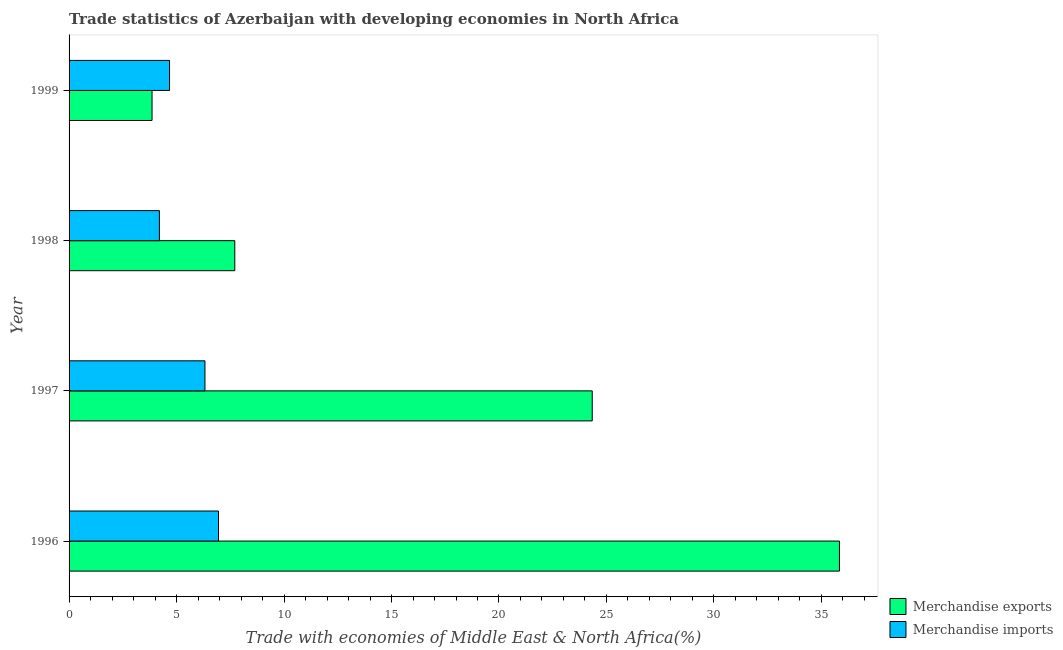How many different coloured bars are there?
Offer a terse response. 2. Are the number of bars on each tick of the Y-axis equal?
Provide a succinct answer. Yes. How many bars are there on the 4th tick from the top?
Your answer should be compact. 2. How many bars are there on the 4th tick from the bottom?
Keep it short and to the point. 2. What is the label of the 3rd group of bars from the top?
Your response must be concise. 1997. In how many cases, is the number of bars for a given year not equal to the number of legend labels?
Your response must be concise. 0. What is the merchandise imports in 1996?
Provide a succinct answer. 6.95. Across all years, what is the maximum merchandise exports?
Your response must be concise. 35.84. Across all years, what is the minimum merchandise exports?
Keep it short and to the point. 3.86. What is the total merchandise imports in the graph?
Your response must be concise. 22.15. What is the difference between the merchandise exports in 1997 and that in 1998?
Your response must be concise. 16.63. What is the difference between the merchandise exports in 1999 and the merchandise imports in 1998?
Your answer should be very brief. -0.34. What is the average merchandise imports per year?
Keep it short and to the point. 5.54. In the year 1996, what is the difference between the merchandise exports and merchandise imports?
Give a very brief answer. 28.89. In how many years, is the merchandise imports greater than 7 %?
Provide a succinct answer. 0. What is the ratio of the merchandise exports in 1996 to that in 1999?
Keep it short and to the point. 9.29. Is the merchandise exports in 1996 less than that in 1999?
Make the answer very short. No. Is the difference between the merchandise exports in 1997 and 1998 greater than the difference between the merchandise imports in 1997 and 1998?
Your response must be concise. Yes. What is the difference between the highest and the lowest merchandise imports?
Ensure brevity in your answer.  2.75. Is the sum of the merchandise exports in 1996 and 1999 greater than the maximum merchandise imports across all years?
Offer a very short reply. Yes. What does the 2nd bar from the top in 1999 represents?
Provide a short and direct response. Merchandise exports. How many years are there in the graph?
Your response must be concise. 4. What is the difference between two consecutive major ticks on the X-axis?
Make the answer very short. 5. Does the graph contain any zero values?
Your response must be concise. No. Does the graph contain grids?
Give a very brief answer. No. Where does the legend appear in the graph?
Provide a short and direct response. Bottom right. How many legend labels are there?
Your answer should be compact. 2. What is the title of the graph?
Provide a short and direct response. Trade statistics of Azerbaijan with developing economies in North Africa. What is the label or title of the X-axis?
Offer a terse response. Trade with economies of Middle East & North Africa(%). What is the label or title of the Y-axis?
Keep it short and to the point. Year. What is the Trade with economies of Middle East & North Africa(%) of Merchandise exports in 1996?
Provide a succinct answer. 35.84. What is the Trade with economies of Middle East & North Africa(%) of Merchandise imports in 1996?
Your answer should be compact. 6.95. What is the Trade with economies of Middle East & North Africa(%) in Merchandise exports in 1997?
Ensure brevity in your answer.  24.34. What is the Trade with economies of Middle East & North Africa(%) in Merchandise imports in 1997?
Keep it short and to the point. 6.32. What is the Trade with economies of Middle East & North Africa(%) in Merchandise exports in 1998?
Give a very brief answer. 7.71. What is the Trade with economies of Middle East & North Africa(%) of Merchandise imports in 1998?
Provide a short and direct response. 4.2. What is the Trade with economies of Middle East & North Africa(%) of Merchandise exports in 1999?
Your response must be concise. 3.86. What is the Trade with economies of Middle East & North Africa(%) in Merchandise imports in 1999?
Make the answer very short. 4.67. Across all years, what is the maximum Trade with economies of Middle East & North Africa(%) in Merchandise exports?
Ensure brevity in your answer.  35.84. Across all years, what is the maximum Trade with economies of Middle East & North Africa(%) of Merchandise imports?
Keep it short and to the point. 6.95. Across all years, what is the minimum Trade with economies of Middle East & North Africa(%) in Merchandise exports?
Offer a terse response. 3.86. Across all years, what is the minimum Trade with economies of Middle East & North Africa(%) of Merchandise imports?
Ensure brevity in your answer.  4.2. What is the total Trade with economies of Middle East & North Africa(%) of Merchandise exports in the graph?
Your response must be concise. 71.75. What is the total Trade with economies of Middle East & North Africa(%) in Merchandise imports in the graph?
Provide a succinct answer. 22.15. What is the difference between the Trade with economies of Middle East & North Africa(%) in Merchandise exports in 1996 and that in 1997?
Offer a very short reply. 11.5. What is the difference between the Trade with economies of Middle East & North Africa(%) in Merchandise imports in 1996 and that in 1997?
Make the answer very short. 0.63. What is the difference between the Trade with economies of Middle East & North Africa(%) in Merchandise exports in 1996 and that in 1998?
Give a very brief answer. 28.13. What is the difference between the Trade with economies of Middle East & North Africa(%) of Merchandise imports in 1996 and that in 1998?
Offer a very short reply. 2.75. What is the difference between the Trade with economies of Middle East & North Africa(%) in Merchandise exports in 1996 and that in 1999?
Your answer should be compact. 31.98. What is the difference between the Trade with economies of Middle East & North Africa(%) in Merchandise imports in 1996 and that in 1999?
Your response must be concise. 2.28. What is the difference between the Trade with economies of Middle East & North Africa(%) of Merchandise exports in 1997 and that in 1998?
Your response must be concise. 16.63. What is the difference between the Trade with economies of Middle East & North Africa(%) of Merchandise imports in 1997 and that in 1998?
Your answer should be compact. 2.12. What is the difference between the Trade with economies of Middle East & North Africa(%) in Merchandise exports in 1997 and that in 1999?
Your answer should be compact. 20.48. What is the difference between the Trade with economies of Middle East & North Africa(%) in Merchandise imports in 1997 and that in 1999?
Ensure brevity in your answer.  1.65. What is the difference between the Trade with economies of Middle East & North Africa(%) in Merchandise exports in 1998 and that in 1999?
Give a very brief answer. 3.85. What is the difference between the Trade with economies of Middle East & North Africa(%) of Merchandise imports in 1998 and that in 1999?
Ensure brevity in your answer.  -0.47. What is the difference between the Trade with economies of Middle East & North Africa(%) in Merchandise exports in 1996 and the Trade with economies of Middle East & North Africa(%) in Merchandise imports in 1997?
Ensure brevity in your answer.  29.52. What is the difference between the Trade with economies of Middle East & North Africa(%) in Merchandise exports in 1996 and the Trade with economies of Middle East & North Africa(%) in Merchandise imports in 1998?
Provide a succinct answer. 31.64. What is the difference between the Trade with economies of Middle East & North Africa(%) of Merchandise exports in 1996 and the Trade with economies of Middle East & North Africa(%) of Merchandise imports in 1999?
Make the answer very short. 31.16. What is the difference between the Trade with economies of Middle East & North Africa(%) in Merchandise exports in 1997 and the Trade with economies of Middle East & North Africa(%) in Merchandise imports in 1998?
Provide a succinct answer. 20.14. What is the difference between the Trade with economies of Middle East & North Africa(%) in Merchandise exports in 1997 and the Trade with economies of Middle East & North Africa(%) in Merchandise imports in 1999?
Your answer should be very brief. 19.66. What is the difference between the Trade with economies of Middle East & North Africa(%) in Merchandise exports in 1998 and the Trade with economies of Middle East & North Africa(%) in Merchandise imports in 1999?
Offer a terse response. 3.04. What is the average Trade with economies of Middle East & North Africa(%) in Merchandise exports per year?
Provide a short and direct response. 17.94. What is the average Trade with economies of Middle East & North Africa(%) in Merchandise imports per year?
Provide a succinct answer. 5.54. In the year 1996, what is the difference between the Trade with economies of Middle East & North Africa(%) in Merchandise exports and Trade with economies of Middle East & North Africa(%) in Merchandise imports?
Offer a very short reply. 28.89. In the year 1997, what is the difference between the Trade with economies of Middle East & North Africa(%) in Merchandise exports and Trade with economies of Middle East & North Africa(%) in Merchandise imports?
Offer a terse response. 18.02. In the year 1998, what is the difference between the Trade with economies of Middle East & North Africa(%) in Merchandise exports and Trade with economies of Middle East & North Africa(%) in Merchandise imports?
Keep it short and to the point. 3.51. In the year 1999, what is the difference between the Trade with economies of Middle East & North Africa(%) of Merchandise exports and Trade with economies of Middle East & North Africa(%) of Merchandise imports?
Keep it short and to the point. -0.81. What is the ratio of the Trade with economies of Middle East & North Africa(%) in Merchandise exports in 1996 to that in 1997?
Provide a succinct answer. 1.47. What is the ratio of the Trade with economies of Middle East & North Africa(%) of Merchandise imports in 1996 to that in 1997?
Your answer should be compact. 1.1. What is the ratio of the Trade with economies of Middle East & North Africa(%) of Merchandise exports in 1996 to that in 1998?
Ensure brevity in your answer.  4.65. What is the ratio of the Trade with economies of Middle East & North Africa(%) of Merchandise imports in 1996 to that in 1998?
Provide a succinct answer. 1.65. What is the ratio of the Trade with economies of Middle East & North Africa(%) of Merchandise exports in 1996 to that in 1999?
Your answer should be very brief. 9.28. What is the ratio of the Trade with economies of Middle East & North Africa(%) in Merchandise imports in 1996 to that in 1999?
Keep it short and to the point. 1.49. What is the ratio of the Trade with economies of Middle East & North Africa(%) of Merchandise exports in 1997 to that in 1998?
Give a very brief answer. 3.16. What is the ratio of the Trade with economies of Middle East & North Africa(%) of Merchandise imports in 1997 to that in 1998?
Ensure brevity in your answer.  1.5. What is the ratio of the Trade with economies of Middle East & North Africa(%) of Merchandise exports in 1997 to that in 1999?
Your response must be concise. 6.31. What is the ratio of the Trade with economies of Middle East & North Africa(%) of Merchandise imports in 1997 to that in 1999?
Provide a succinct answer. 1.35. What is the ratio of the Trade with economies of Middle East & North Africa(%) in Merchandise exports in 1998 to that in 1999?
Offer a terse response. 2. What is the ratio of the Trade with economies of Middle East & North Africa(%) of Merchandise imports in 1998 to that in 1999?
Provide a succinct answer. 0.9. What is the difference between the highest and the second highest Trade with economies of Middle East & North Africa(%) in Merchandise exports?
Your answer should be very brief. 11.5. What is the difference between the highest and the second highest Trade with economies of Middle East & North Africa(%) in Merchandise imports?
Provide a short and direct response. 0.63. What is the difference between the highest and the lowest Trade with economies of Middle East & North Africa(%) in Merchandise exports?
Offer a terse response. 31.98. What is the difference between the highest and the lowest Trade with economies of Middle East & North Africa(%) of Merchandise imports?
Offer a terse response. 2.75. 